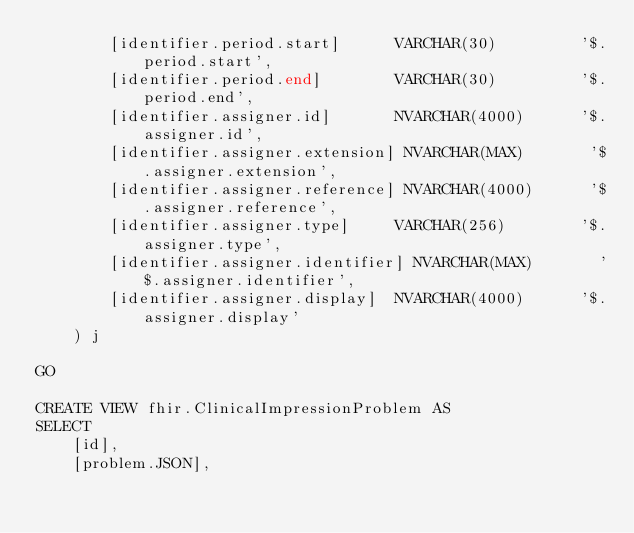<code> <loc_0><loc_0><loc_500><loc_500><_SQL_>        [identifier.period.start]      VARCHAR(30)         '$.period.start',
        [identifier.period.end]        VARCHAR(30)         '$.period.end',
        [identifier.assigner.id]       NVARCHAR(4000)      '$.assigner.id',
        [identifier.assigner.extension] NVARCHAR(MAX)       '$.assigner.extension',
        [identifier.assigner.reference] NVARCHAR(4000)      '$.assigner.reference',
        [identifier.assigner.type]     VARCHAR(256)        '$.assigner.type',
        [identifier.assigner.identifier] NVARCHAR(MAX)       '$.assigner.identifier',
        [identifier.assigner.display]  NVARCHAR(4000)      '$.assigner.display'
    ) j

GO

CREATE VIEW fhir.ClinicalImpressionProblem AS
SELECT
    [id],
    [problem.JSON],</code> 